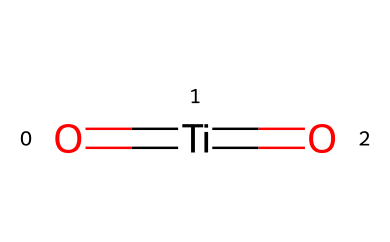What is the chemical formula of this compound? The SMILES representation shows the atoms present in the molecule: titanium (Ti) and oxygen (O). The formula can be deduced directly from these symbols as TiO2, representing one titanium atom and two oxygen atoms.
Answer: TiO2 How many oxygen atoms are in the molecular structure? The SMILES representation contains two instances of the oxygen (O) symbol, indicating that there are two oxygen atoms connected to the titanium atom.
Answer: 2 What type of bonds are present in this molecule? The structure shows that titanium is double-bonded to each oxygen atom (as indicated by the '=' signs in the SMILES). This indicates that the molecule has double bonds.
Answer: double bonds Is titanium dioxide typically considered hazardous? Titanium dioxide is a compound that, while used safely in many applications, can be hazardous when inhaled in particulate form, primarily affecting the lungs.
Answer: Yes What is the hybridization of the titanium atom in this compound? In the structure, titanium has a coordination of two with double bonds to oxygen atoms. The hybridization of titanium in this case is typically sp due to the linear arrangement of bonds.
Answer: sp What is a common application of titanium dioxide relevant to outdoor climbers? Titanium dioxide is commonly used as a UV filter in sunscreens, providing protection against harmful UV radiation, which is crucial for outdoor climbers who are frequently exposed to the sun.
Answer: sunscreen 